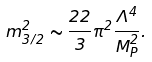<formula> <loc_0><loc_0><loc_500><loc_500>m ^ { 2 } _ { 3 / 2 } \sim \frac { 2 2 } { 3 } \pi ^ { 2 } \frac { \Lambda ^ { 4 } } { M _ { P } ^ { 2 } } .</formula> 